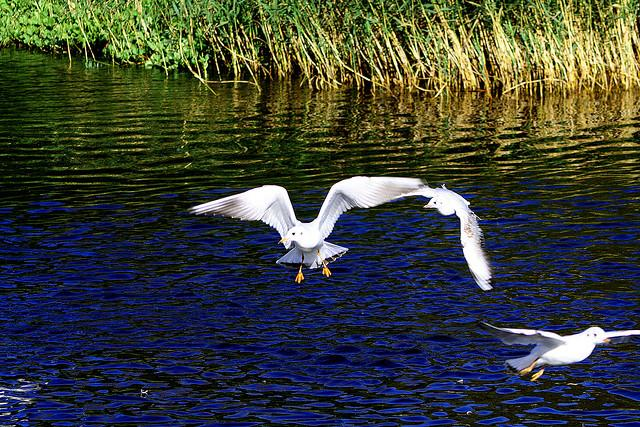What is in the air? Please explain your reasoning. birds. There are seagulls in the air. 